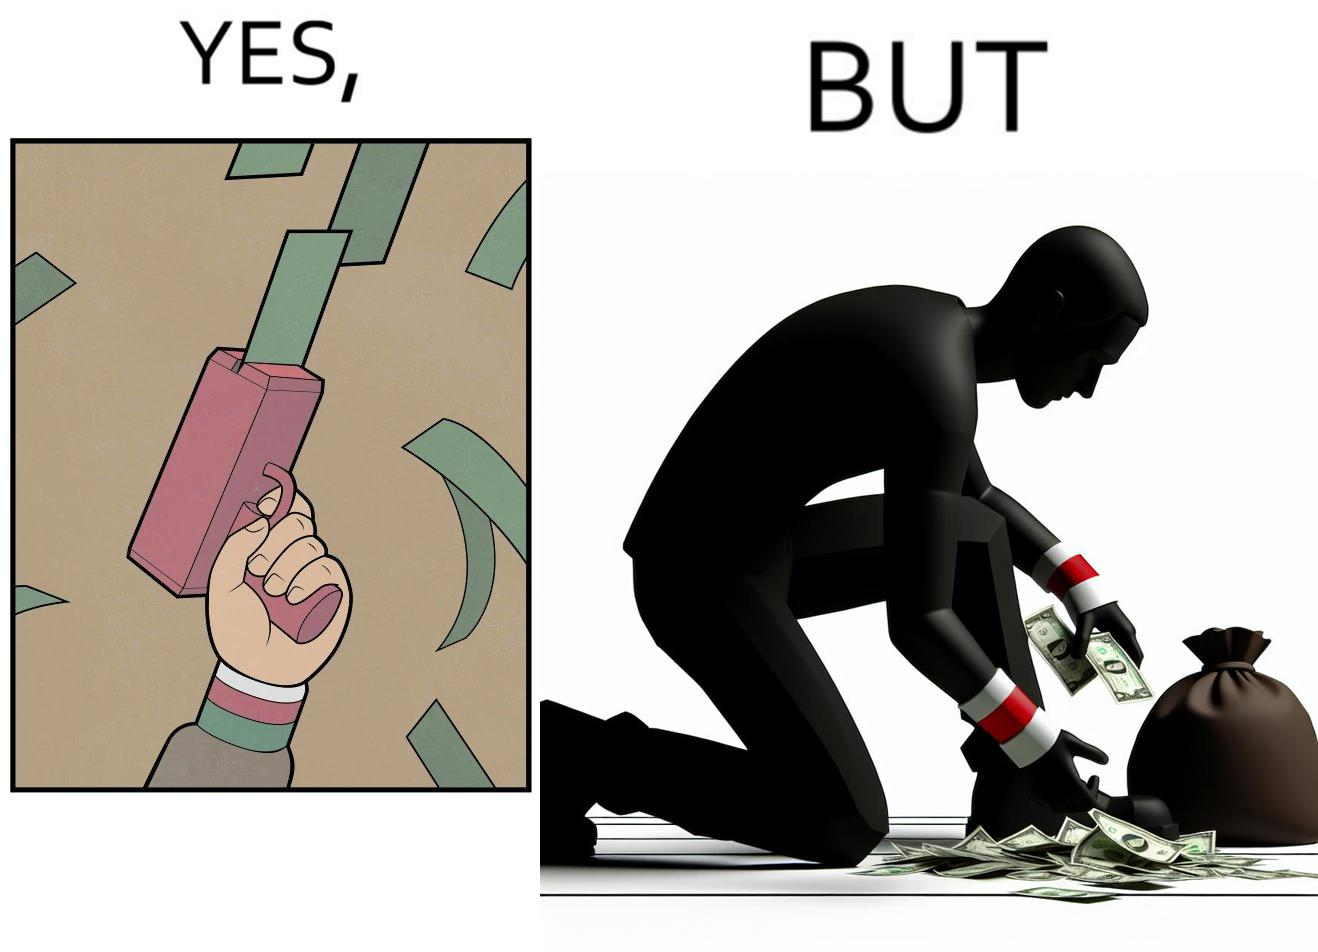Explain the humor or irony in this image. The image is satirical because the man that is shooting money in the air causing a rain of money bills is the same person who is crouching down to collect the fallen dollar bills from the ground which makes the act of shooting bills in the air not so fun. 